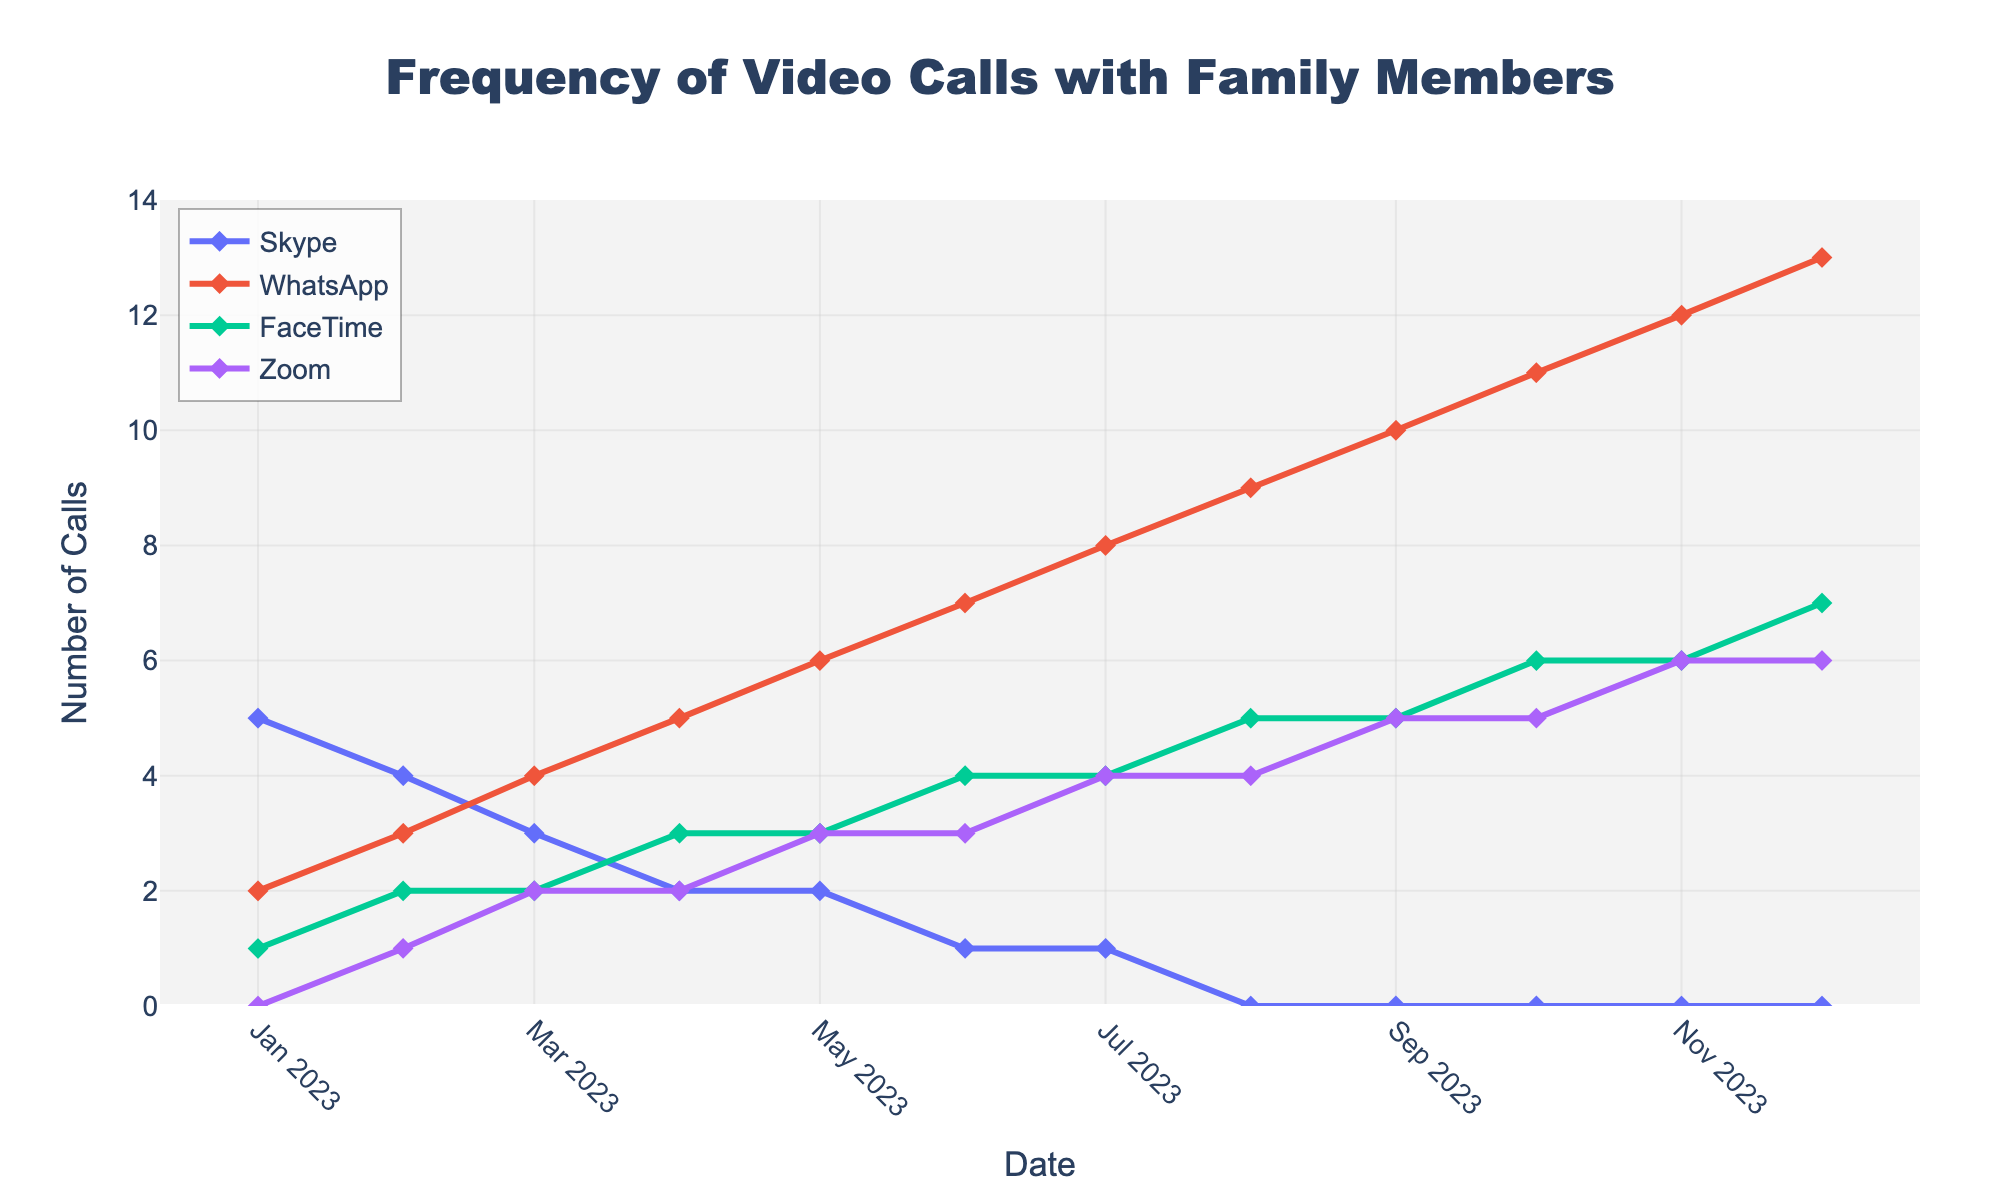What is the overall trend for Skype calls over the year? The frequency of Skype calls starts at 5 in January and gradually decreases to 0 by August, maintaining at 0 till December. This indicates a declining trend.
Answer: Declining Which platform saw the highest increase in call frequency from January to December? From January to December, WhatsApp grew from 2 to 13 calls, accounting for the highest increase of 11 calls.
Answer: WhatsApp In which month did FaceTime calls first reach 5 calls? By scanning the line representing FaceTime, we see it first reaches 5 calls in August.
Answer: August How many total calls were made via Zoom throughout the year? Summing the calls for each month: 0 + 1 + 2 + 2 + 3 + 3 + 4 + 4 + 5 + 5 + 6 + 6 = 41.
Answer: 41 When did WhatsApp calls surpass Skype calls? Initially, Skype had more calls, but WhatsApp surpassed Skype in March when it had 4 calls compared to Skype's 3.
Answer: March Compare the number of FaceTime and Zoom calls in June. Which had more, and by how much? FaceTime had 4 calls while Zoom had 3 calls in June. FaceTime had 1 more call than Zoom.
Answer: FaceTime by 1 call What is the average number of FaceTime calls in the second half of the year (July to December)? The monthly values for FaceTime from July to December are: 4, 5, 5, 6, 6, 7. The average is (4 + 5 + 5 + 6 + 6 + 7)/6 = 5.5.
Answer: 5.5 